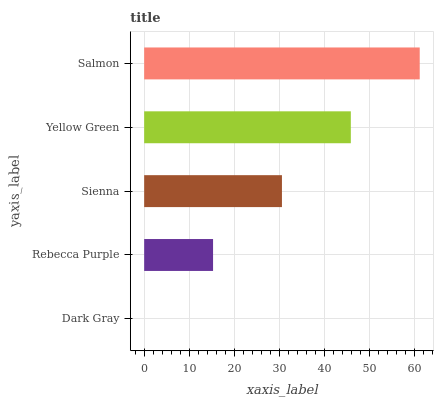Is Dark Gray the minimum?
Answer yes or no. Yes. Is Salmon the maximum?
Answer yes or no. Yes. Is Rebecca Purple the minimum?
Answer yes or no. No. Is Rebecca Purple the maximum?
Answer yes or no. No. Is Rebecca Purple greater than Dark Gray?
Answer yes or no. Yes. Is Dark Gray less than Rebecca Purple?
Answer yes or no. Yes. Is Dark Gray greater than Rebecca Purple?
Answer yes or no. No. Is Rebecca Purple less than Dark Gray?
Answer yes or no. No. Is Sienna the high median?
Answer yes or no. Yes. Is Sienna the low median?
Answer yes or no. Yes. Is Salmon the high median?
Answer yes or no. No. Is Dark Gray the low median?
Answer yes or no. No. 